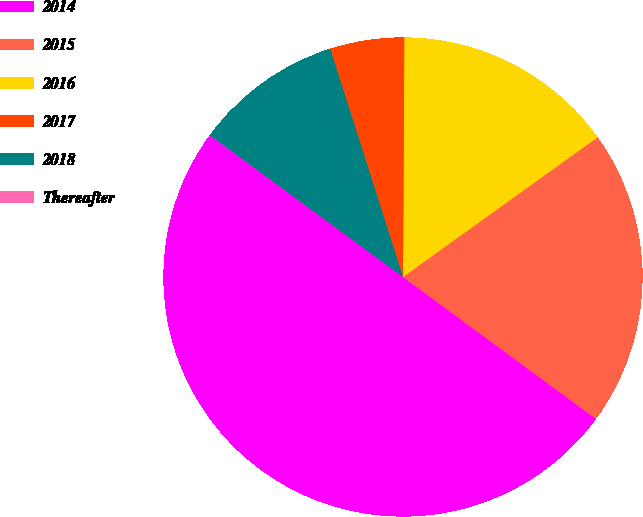<chart> <loc_0><loc_0><loc_500><loc_500><pie_chart><fcel>2014<fcel>2015<fcel>2016<fcel>2017<fcel>2018<fcel>Thereafter<nl><fcel>49.97%<fcel>20.0%<fcel>15.0%<fcel>5.01%<fcel>10.01%<fcel>0.01%<nl></chart> 